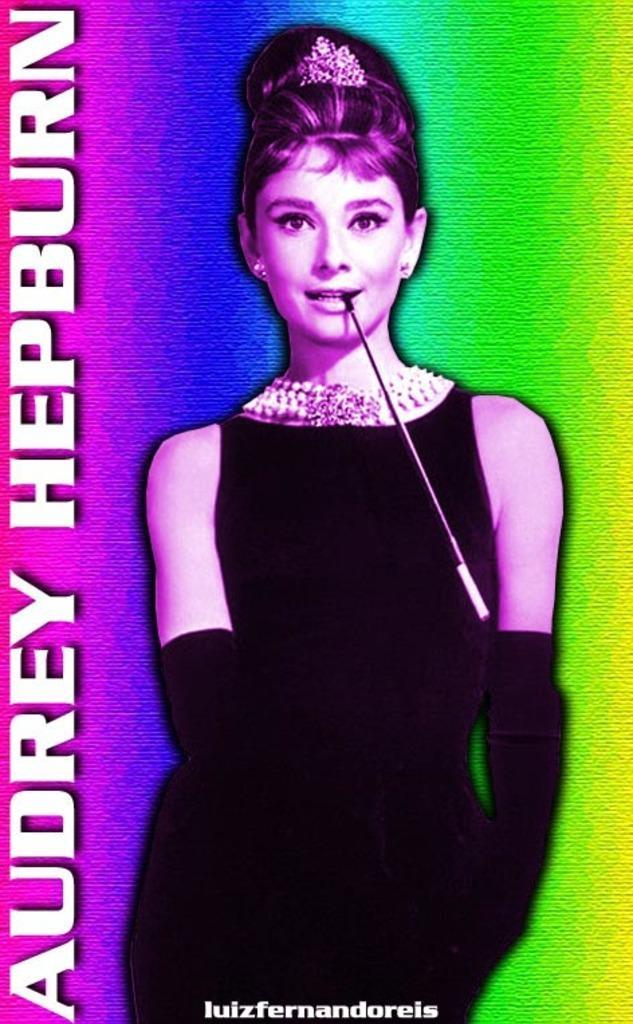Describe this image in one or two sentences. In this picture we can the image of Audrey Hepburn wearing a black dress, black gloves with a white neck piece. 